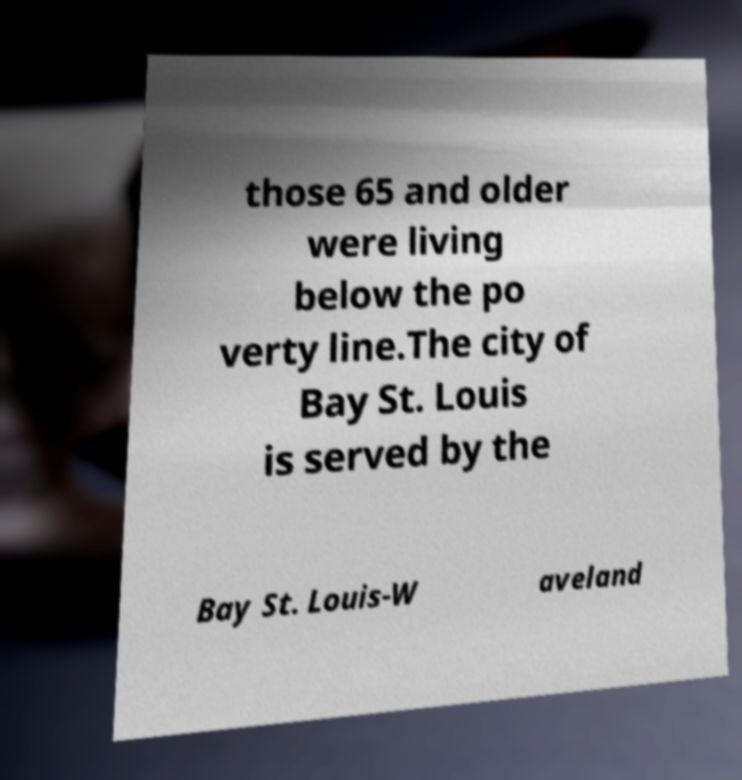Can you accurately transcribe the text from the provided image for me? those 65 and older were living below the po verty line.The city of Bay St. Louis is served by the Bay St. Louis-W aveland 